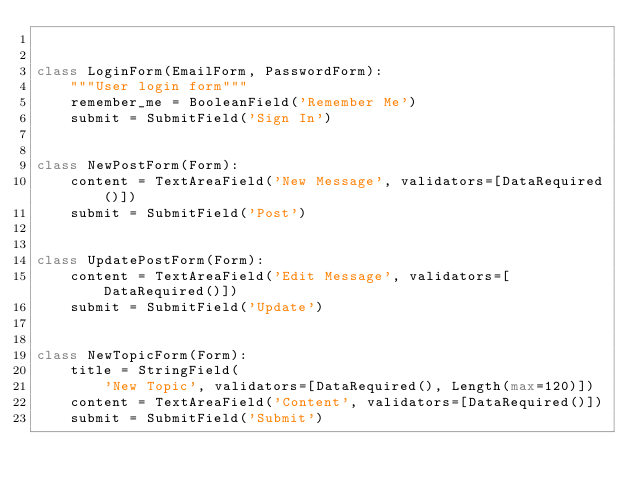Convert code to text. <code><loc_0><loc_0><loc_500><loc_500><_Python_>

class LoginForm(EmailForm, PasswordForm):
    """User login form"""
    remember_me = BooleanField('Remember Me')
    submit = SubmitField('Sign In')


class NewPostForm(Form):
    content = TextAreaField('New Message', validators=[DataRequired()])
    submit = SubmitField('Post')


class UpdatePostForm(Form):
    content = TextAreaField('Edit Message', validators=[DataRequired()])
    submit = SubmitField('Update')


class NewTopicForm(Form):
    title = StringField(
        'New Topic', validators=[DataRequired(), Length(max=120)])
    content = TextAreaField('Content', validators=[DataRequired()])
    submit = SubmitField('Submit')
</code> 